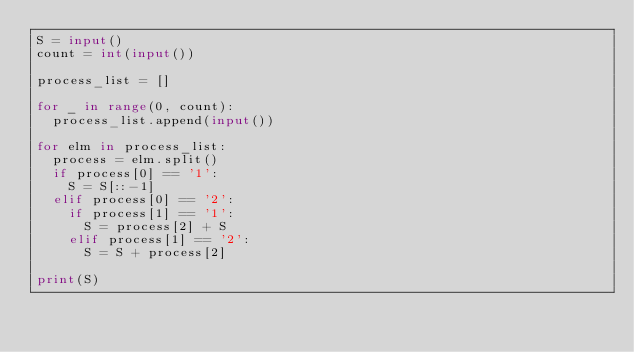Convert code to text. <code><loc_0><loc_0><loc_500><loc_500><_Python_>S = input()
count = int(input())

process_list = []

for _ in range(0, count):
  process_list.append(input())
  
for elm in process_list:
  process = elm.split()
  if process[0] == '1':
    S = S[::-1]
  elif process[0] == '2':
    if process[1] == '1':
      S = process[2] + S
    elif process[1] == '2':
      S = S + process[2]

print(S)</code> 